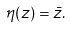<formula> <loc_0><loc_0><loc_500><loc_500>\eta ( z ) = \bar { z } .</formula> 